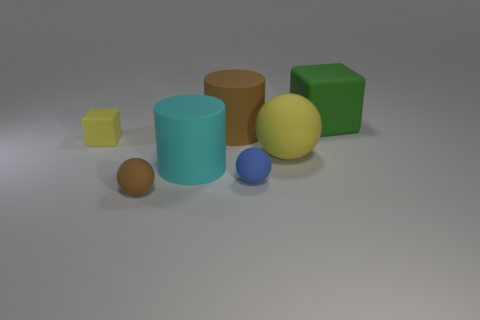What color is the block that is the same size as the brown ball?
Provide a short and direct response. Yellow. Are the big brown cylinder and the big cyan cylinder made of the same material?
Give a very brief answer. Yes. Are there more tiny brown spheres that are in front of the big yellow matte ball than big red metallic cubes?
Offer a very short reply. Yes. What number of other objects are there of the same size as the brown matte cylinder?
Offer a terse response. 3. Is the tiny matte cube the same color as the big sphere?
Make the answer very short. Yes. What is the color of the cube that is right of the cylinder in front of the yellow matte thing that is to the right of the cyan matte cylinder?
Make the answer very short. Green. There is a block in front of the rubber cube that is on the right side of the large cyan cylinder; what number of rubber objects are behind it?
Your answer should be compact. 2. Is there any other thing that is the same color as the small rubber cube?
Offer a very short reply. Yes. There is a yellow object that is behind the yellow rubber ball; is it the same size as the tiny brown object?
Offer a terse response. Yes. There is a yellow rubber thing that is to the left of the big brown cylinder; how many large cyan cylinders are in front of it?
Provide a short and direct response. 1. 